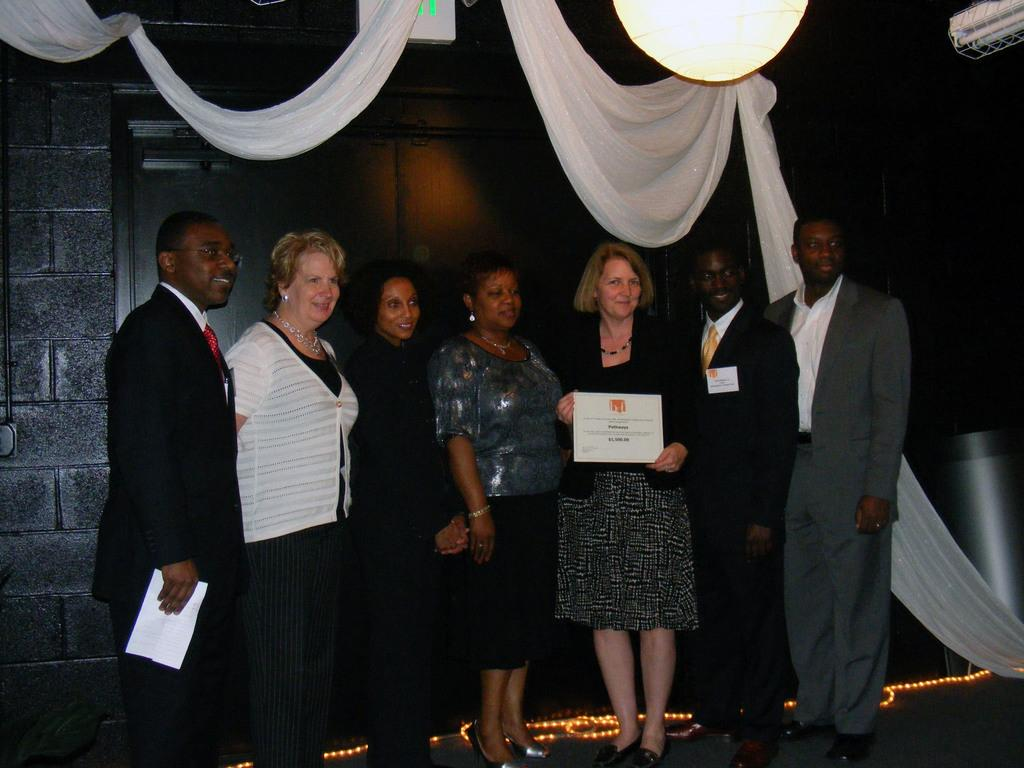How many people are present in the image? There are seven people in the image. What is happening to the woman on the right side of the image? A woman is accepting an award on the right side of the image. What is the price of the dinner being served in the image? There is no dinner being served in the image, so it is not possible to determine the price. 